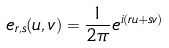Convert formula to latex. <formula><loc_0><loc_0><loc_500><loc_500>e _ { r , s } ( u , v ) = \frac { 1 } { 2 \pi } e ^ { i ( r u + s v ) }</formula> 